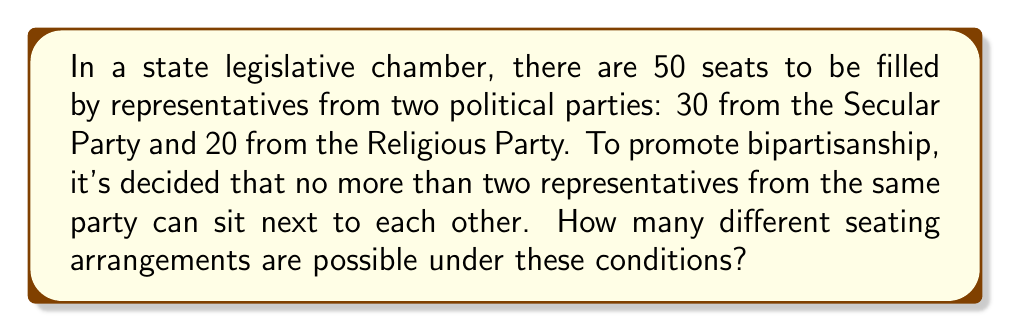Provide a solution to this math problem. Let's approach this step-by-step:

1) First, we need to consider the pattern of seating. Given the conditions, the representatives must alternate between parties in groups of one or two.

2) Let's represent Secular Party members as S and Religious Party members as R. The possible patterns are:
   SRSR, SRRS, RSSR, RSSR

3) We can think of this as arranging 25 blocks, where each block is either SR, RS, SRS, or RSR.

4) The number of SRS blocks can range from 0 to 10, as there are 20 R representatives.

5) Let $x$ be the number of SRS blocks. Then:
   - Number of SR or RS blocks = $25 - 2x$
   - Number of R left to be placed in SR or RS blocks = $20 - x$
   - Number of RS blocks = $20 - x$
   - Number of SR blocks = $(25 - 2x) - (20 - x) = 5 - x$

6) For each value of $x$ from 0 to 10, we need to choose which positions will be SRS blocks. This can be done in $\binom{25}{x}$ ways.

7) After placing the SRS blocks, we need to arrange the RS and SR blocks. This can be done in $\binom{25-x}{20-x}$ ways.

8) Therefore, the total number of arrangements is:

   $$\sum_{x=0}^{10} \binom{25}{x} \binom{25-x}{20-x}$$

9) This sum can be calculated to get the final answer.
Answer: $$\sum_{x=0}^{10} \binom{25}{x} \binom{25-x}{20-x}$$ 